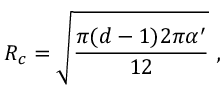<formula> <loc_0><loc_0><loc_500><loc_500>R _ { c } = \sqrt { { \frac { \pi ( d - 1 ) 2 \pi \alpha ^ { \prime } } { 1 2 } } } \ ,</formula> 